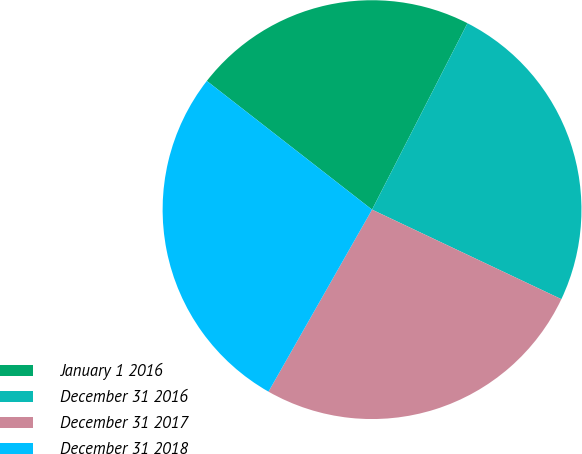Convert chart to OTSL. <chart><loc_0><loc_0><loc_500><loc_500><pie_chart><fcel>January 1 2016<fcel>December 31 2016<fcel>December 31 2017<fcel>December 31 2018<nl><fcel>22.0%<fcel>24.5%<fcel>26.2%<fcel>27.3%<nl></chart> 